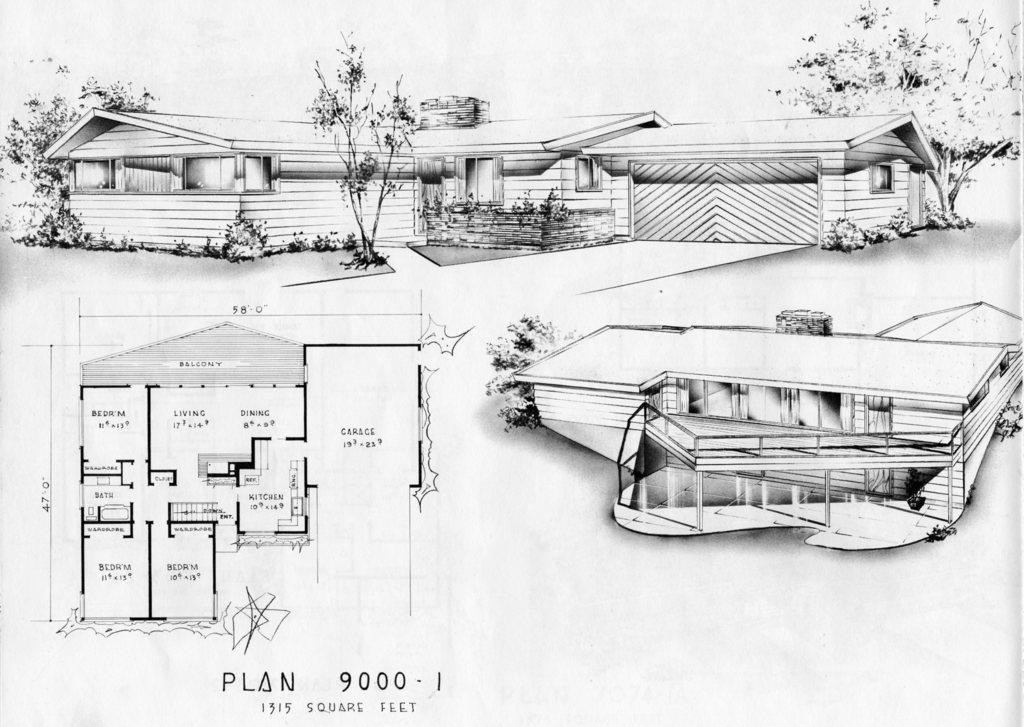How would you summarize this image in a sentence or two? This is the sketch of the houses, trees and a map. 